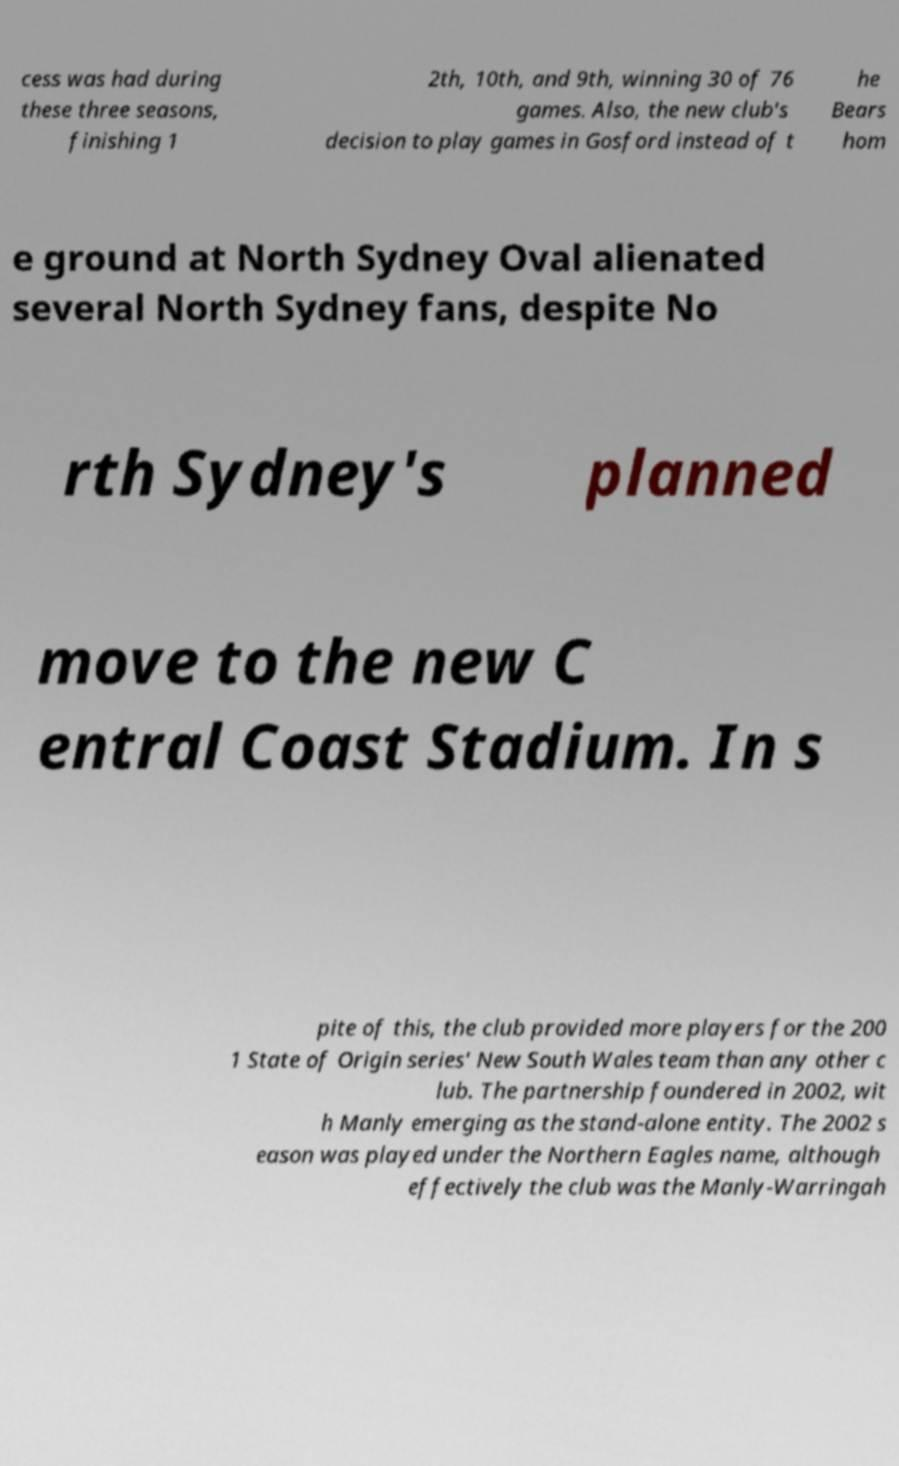I need the written content from this picture converted into text. Can you do that? cess was had during these three seasons, finishing 1 2th, 10th, and 9th, winning 30 of 76 games. Also, the new club's decision to play games in Gosford instead of t he Bears hom e ground at North Sydney Oval alienated several North Sydney fans, despite No rth Sydney's planned move to the new C entral Coast Stadium. In s pite of this, the club provided more players for the 200 1 State of Origin series' New South Wales team than any other c lub. The partnership foundered in 2002, wit h Manly emerging as the stand-alone entity. The 2002 s eason was played under the Northern Eagles name, although effectively the club was the Manly-Warringah 